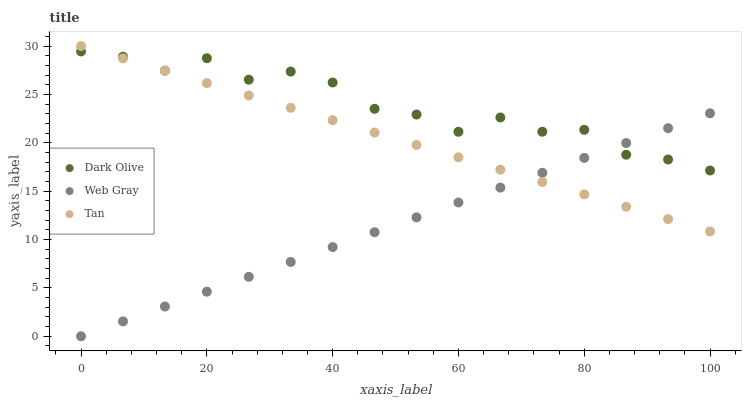Does Web Gray have the minimum area under the curve?
Answer yes or no. Yes. Does Dark Olive have the maximum area under the curve?
Answer yes or no. Yes. Does Dark Olive have the minimum area under the curve?
Answer yes or no. No. Does Web Gray have the maximum area under the curve?
Answer yes or no. No. Is Web Gray the smoothest?
Answer yes or no. Yes. Is Dark Olive the roughest?
Answer yes or no. Yes. Is Dark Olive the smoothest?
Answer yes or no. No. Is Web Gray the roughest?
Answer yes or no. No. Does Web Gray have the lowest value?
Answer yes or no. Yes. Does Dark Olive have the lowest value?
Answer yes or no. No. Does Tan have the highest value?
Answer yes or no. Yes. Does Dark Olive have the highest value?
Answer yes or no. No. Does Web Gray intersect Tan?
Answer yes or no. Yes. Is Web Gray less than Tan?
Answer yes or no. No. Is Web Gray greater than Tan?
Answer yes or no. No. 